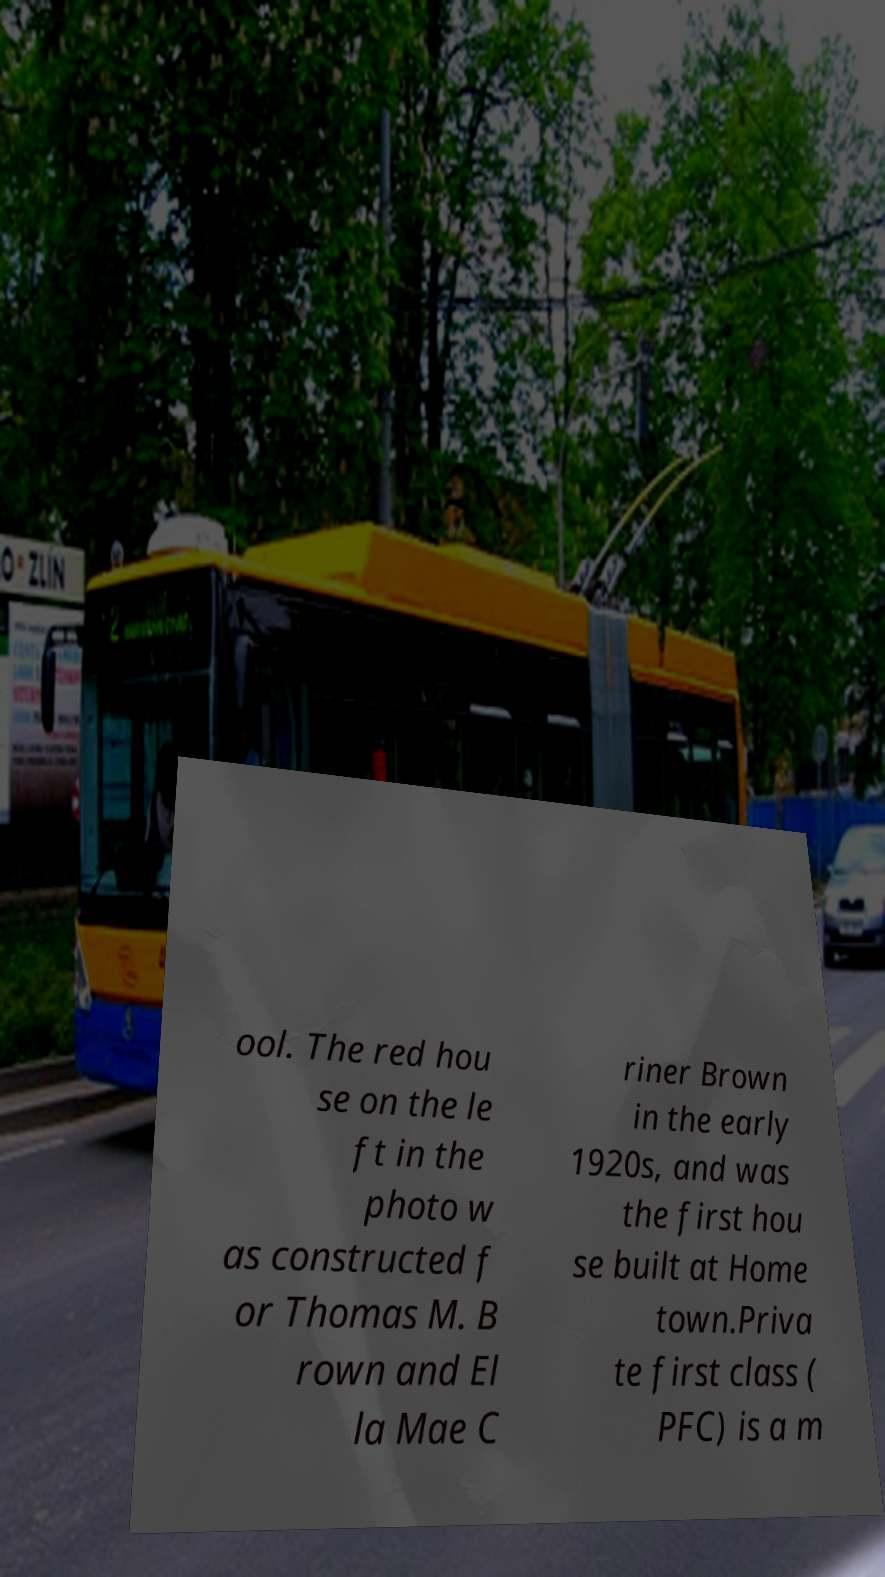Could you extract and type out the text from this image? ool. The red hou se on the le ft in the photo w as constructed f or Thomas M. B rown and El la Mae C riner Brown in the early 1920s, and was the first hou se built at Home town.Priva te first class ( PFC) is a m 